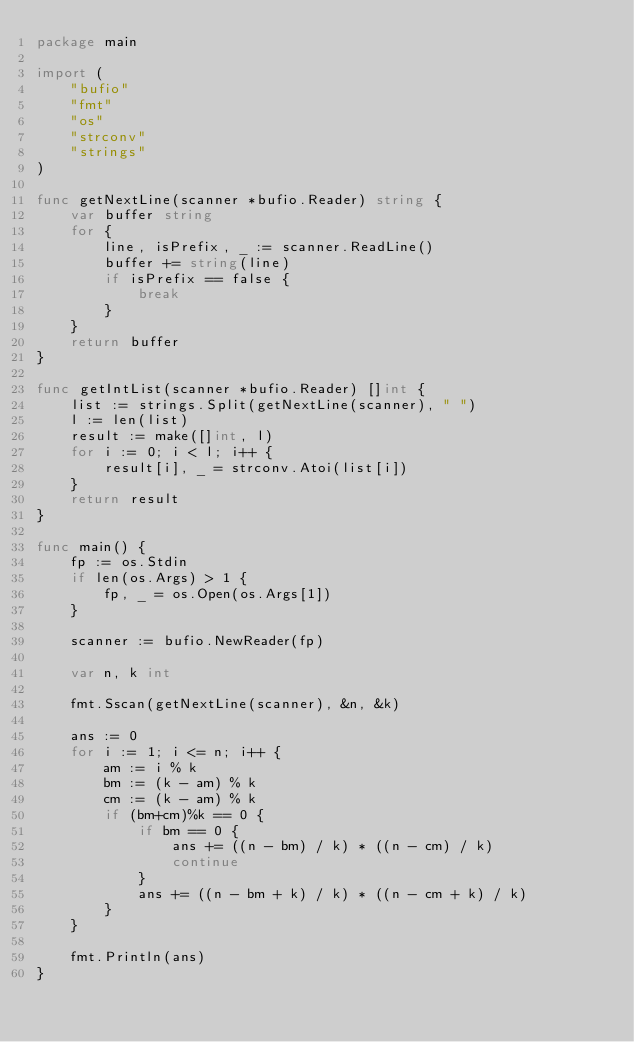<code> <loc_0><loc_0><loc_500><loc_500><_Go_>package main

import (
	"bufio"
	"fmt"
	"os"
	"strconv"
	"strings"
)

func getNextLine(scanner *bufio.Reader) string {
	var buffer string
	for {
		line, isPrefix, _ := scanner.ReadLine()
		buffer += string(line)
		if isPrefix == false {
			break
		}
	}
	return buffer
}

func getIntList(scanner *bufio.Reader) []int {
	list := strings.Split(getNextLine(scanner), " ")
	l := len(list)
	result := make([]int, l)
	for i := 0; i < l; i++ {
		result[i], _ = strconv.Atoi(list[i])
	}
	return result
}

func main() {
	fp := os.Stdin
	if len(os.Args) > 1 {
		fp, _ = os.Open(os.Args[1])
	}

	scanner := bufio.NewReader(fp)

	var n, k int

	fmt.Sscan(getNextLine(scanner), &n, &k)

	ans := 0
	for i := 1; i <= n; i++ {
		am := i % k
		bm := (k - am) % k
		cm := (k - am) % k
		if (bm+cm)%k == 0 {
			if bm == 0 {
				ans += ((n - bm) / k) * ((n - cm) / k)
				continue
			}
			ans += ((n - bm + k) / k) * ((n - cm + k) / k)
		}
	}

	fmt.Println(ans)
}
</code> 